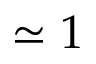<formula> <loc_0><loc_0><loc_500><loc_500>\simeq 1</formula> 